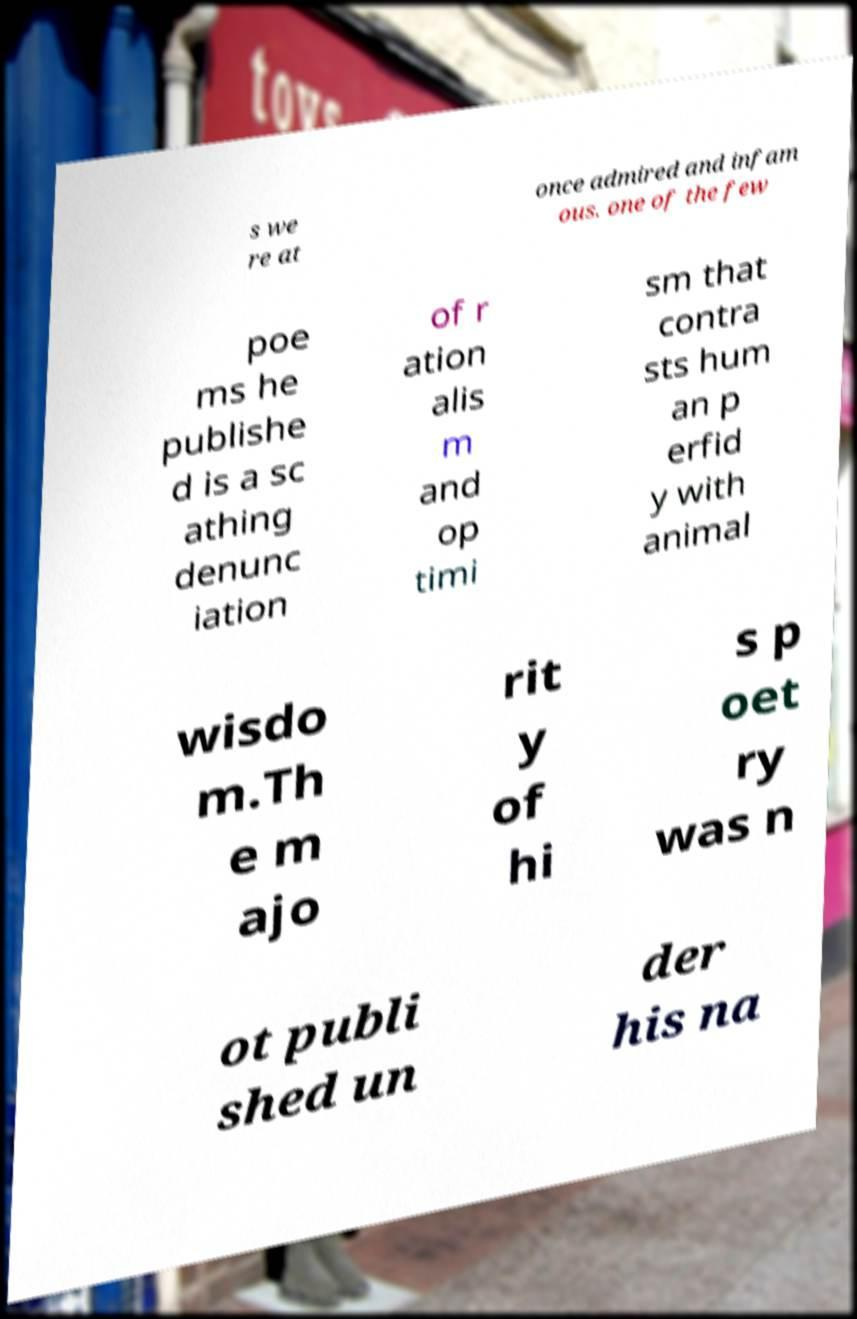Could you assist in decoding the text presented in this image and type it out clearly? s we re at once admired and infam ous. one of the few poe ms he publishe d is a sc athing denunc iation of r ation alis m and op timi sm that contra sts hum an p erfid y with animal wisdo m.Th e m ajo rit y of hi s p oet ry was n ot publi shed un der his na 